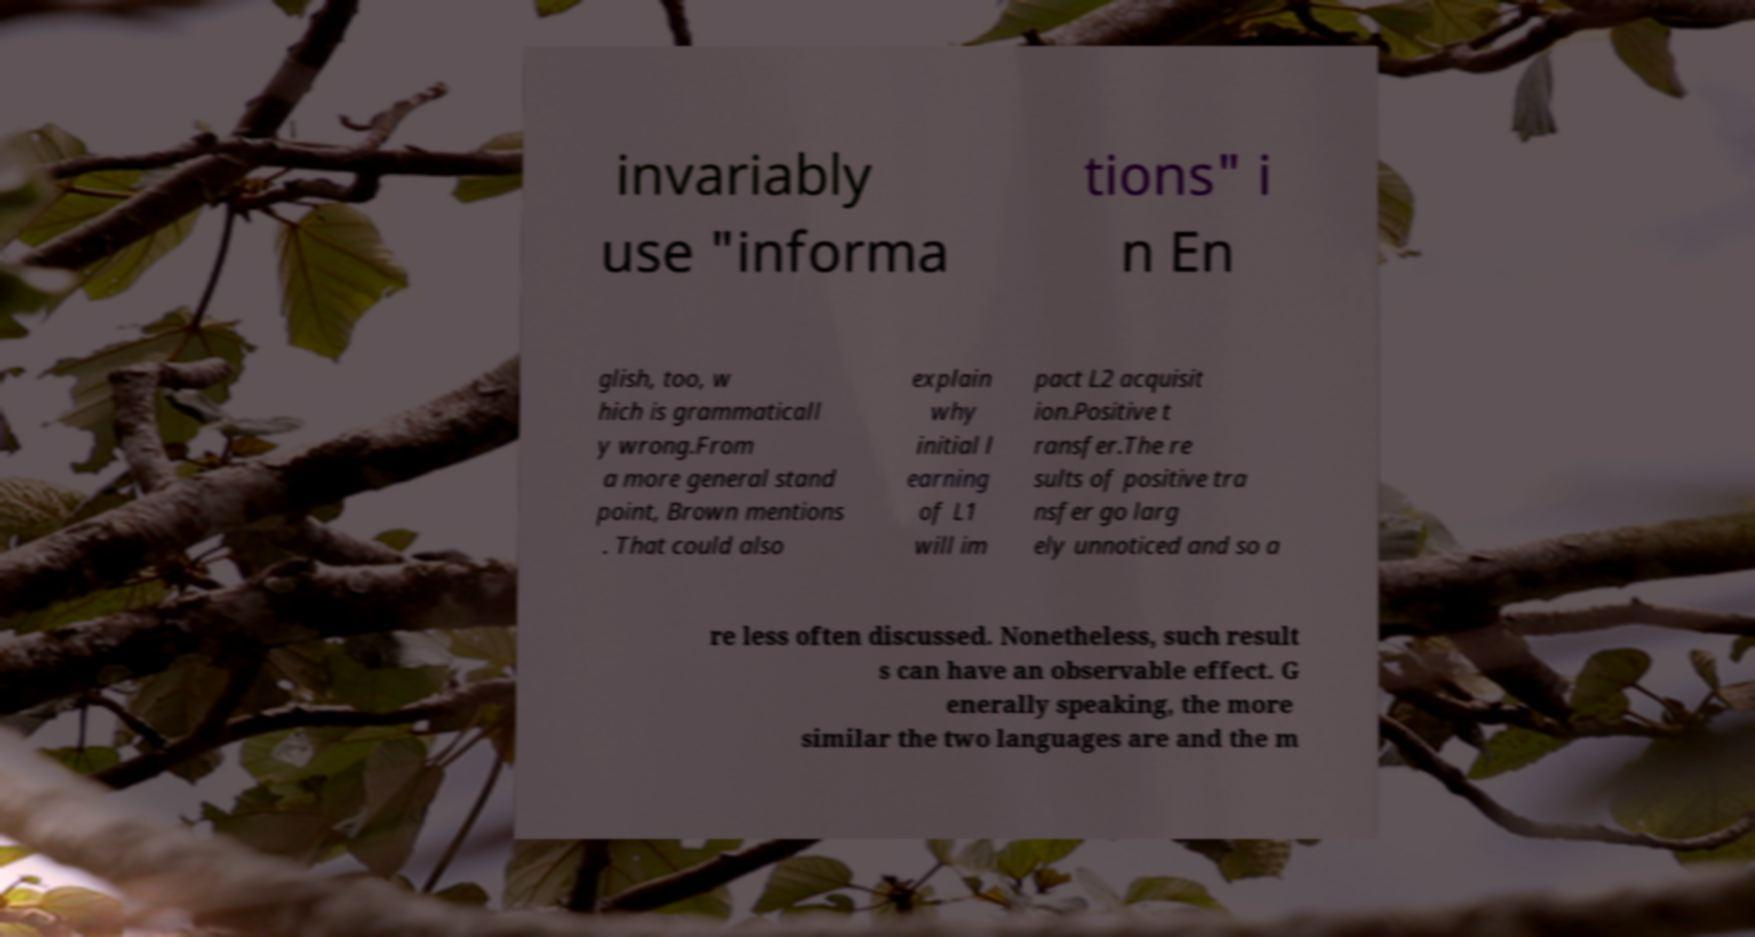Can you accurately transcribe the text from the provided image for me? invariably use "informa tions" i n En glish, too, w hich is grammaticall y wrong.From a more general stand point, Brown mentions . That could also explain why initial l earning of L1 will im pact L2 acquisit ion.Positive t ransfer.The re sults of positive tra nsfer go larg ely unnoticed and so a re less often discussed. Nonetheless, such result s can have an observable effect. G enerally speaking, the more similar the two languages are and the m 